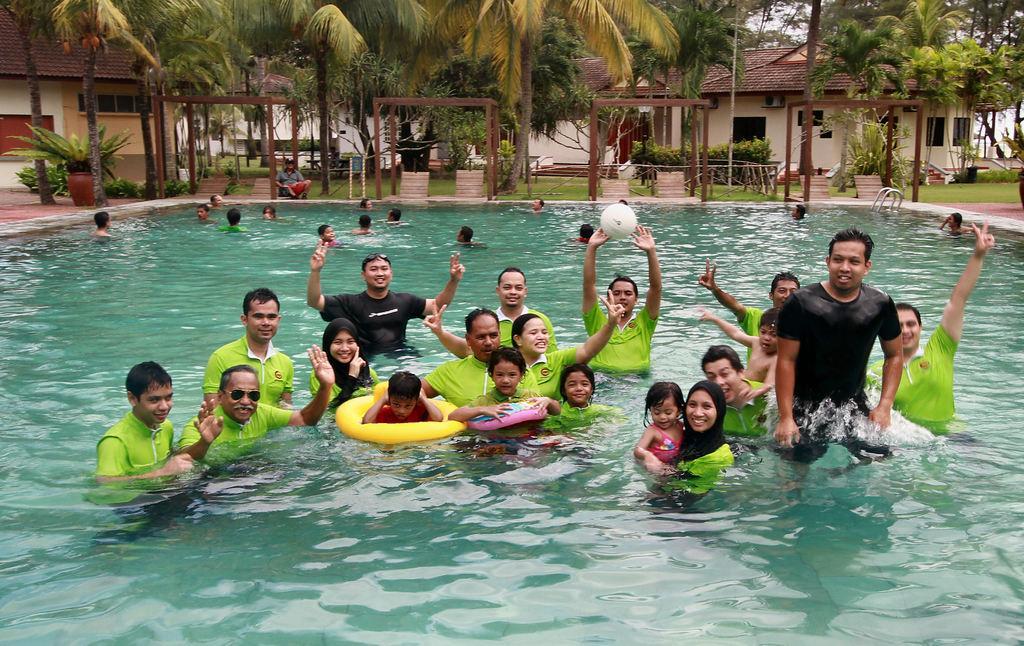In one or two sentences, can you explain what this image depicts? In this image we can see a group of people in a swimming pool. In that a woman is carrying a child, a man is touching a ball and two children are wearing the swimming tubes. On the backside we can see the metal poles, benches, a person sitting on the ground, some plants, a plant in a pot, grass, the wooden poles, a group of trees, some houses with roof and windows and the sky. 